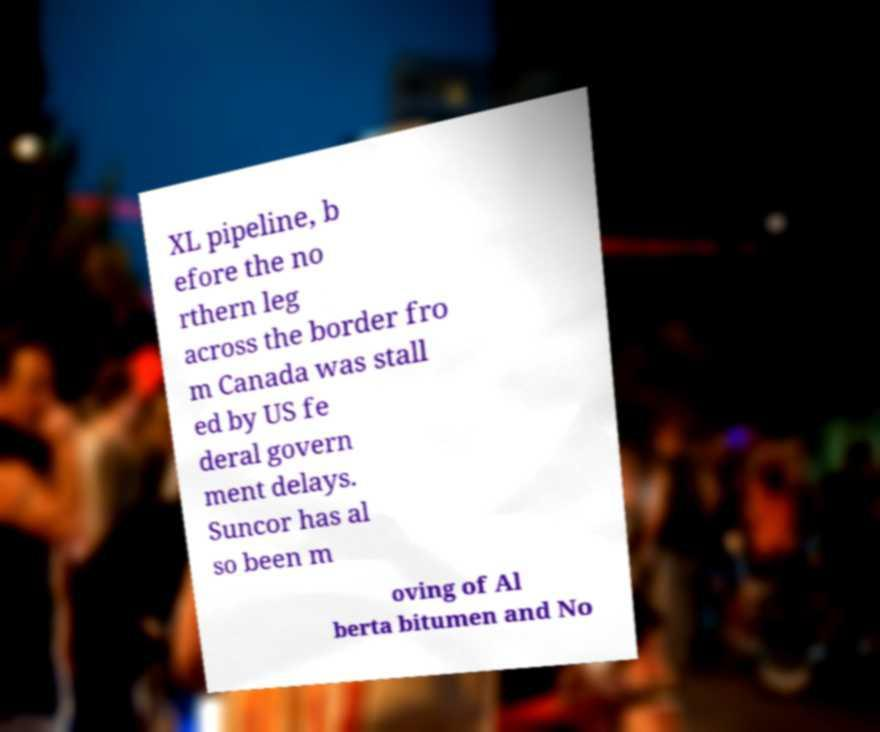For documentation purposes, I need the text within this image transcribed. Could you provide that? XL pipeline, b efore the no rthern leg across the border fro m Canada was stall ed by US fe deral govern ment delays. Suncor has al so been m oving of Al berta bitumen and No 